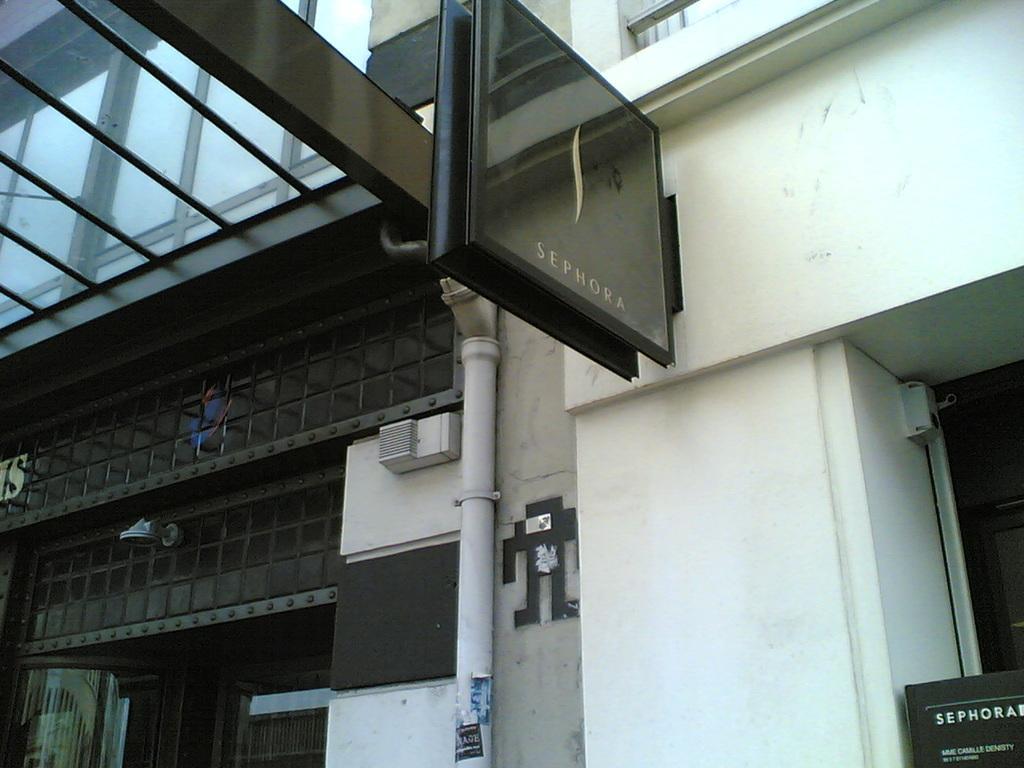How would you summarize this image in a sentence or two? In the center of the image we can see a building and there is a board placed on the wall. 